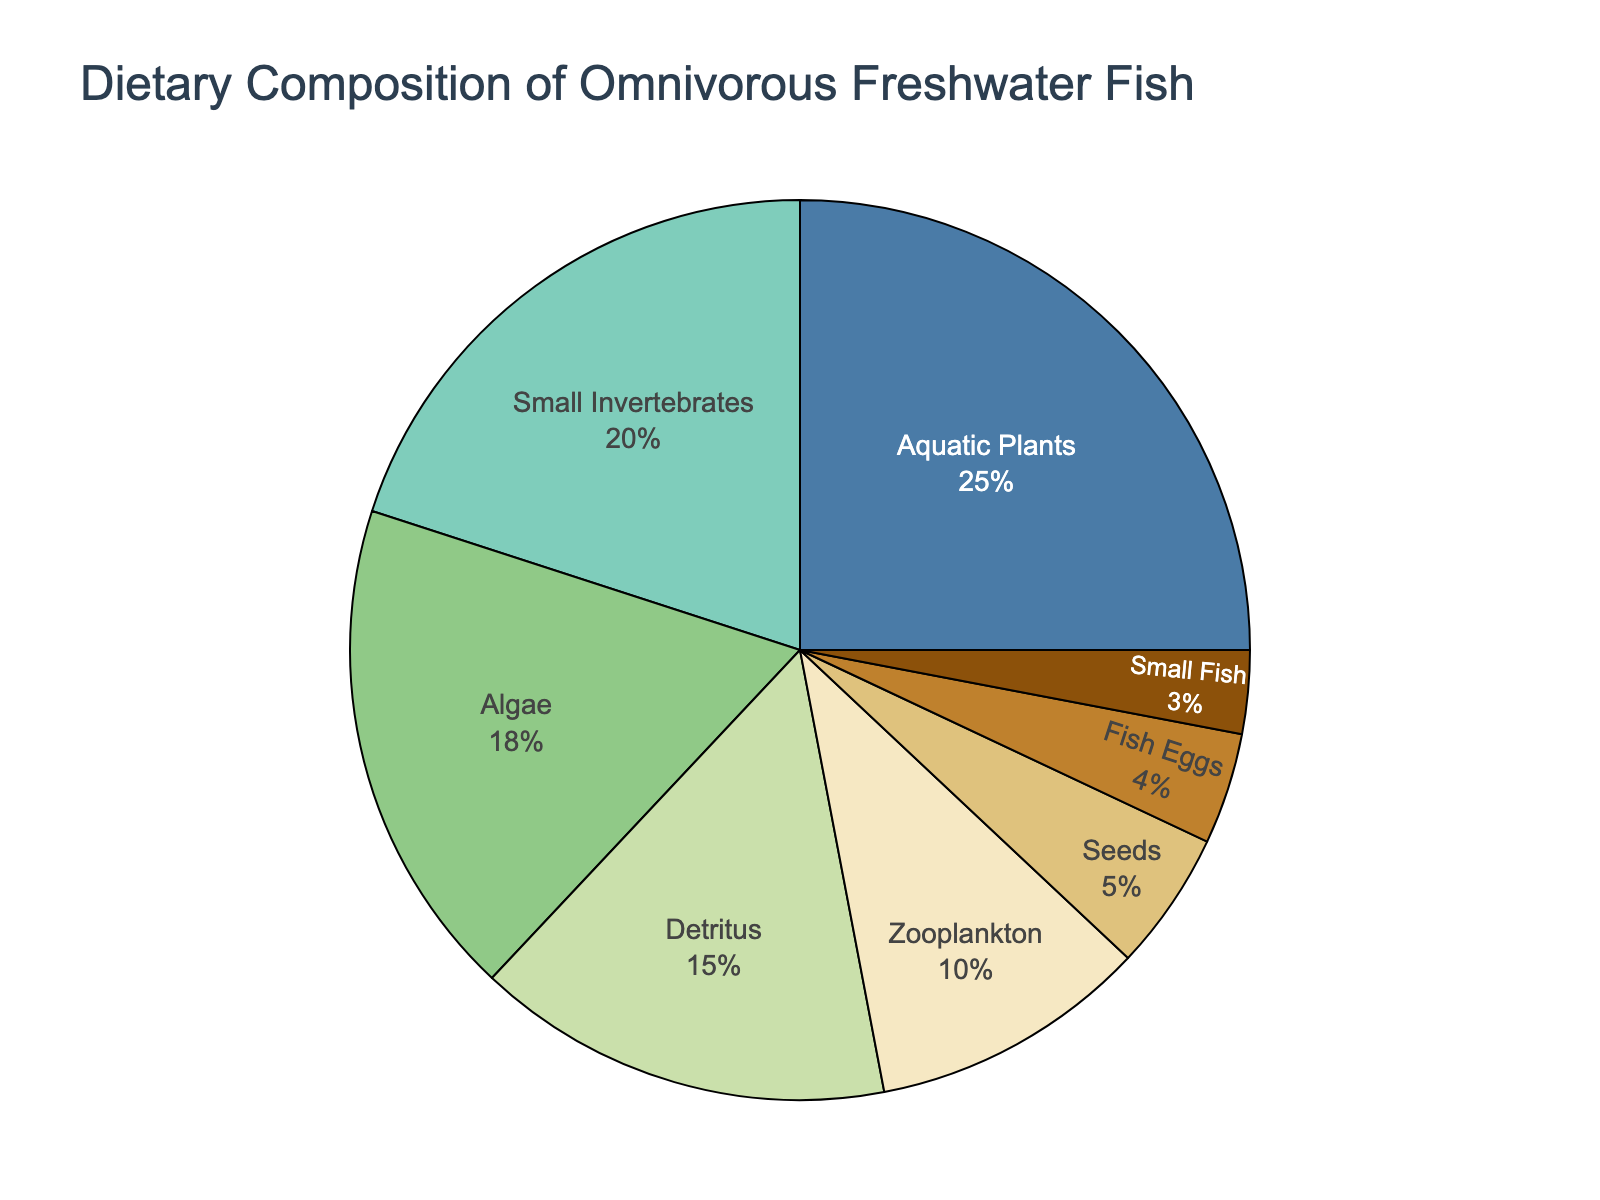What is the most common food item in the diet of omnivorous freshwater fish? The largest segment in the pie chart corresponds to "Aquatic Plants," which makes up 25% of the diet.
Answer: Aquatic Plants Which food item contributes the least to the diet of omnivorous freshwater fish? The smallest segment in the pie chart corresponds to "Small Fish," which makes up 3% of the diet.
Answer: Small Fish What is the difference in percentage between the consumption of aquatic plants and zooplankton? Aquatic Plants make up 25% of the diet, while Zooplankton make up 10%. The difference is 25% - 10% = 15%.
Answer: 15% Are algae consumed more or less than small invertebrates? Algae account for 18% and Small Invertebrates account for 20% of the diet. Therefore, Algae are consumed less.
Answer: Less What percentage of the diet is composed of seeds and fish eggs combined? Seeds make up 5% and Fish Eggs make up 4%. The combined percentage is 5% + 4% = 9%.
Answer: 9% How does the consumption of detritus compare to the consumption of algae? Detritus makes up 15% of the diet, while Algae make up 18%. Therefore, Detritus consumption is less than Algae.
Answer: Less Which food items make up more than 15% of the diet? The segments labeled "Aquatic Plants" (25%) and "Small Invertebrates" (20%) each make up more than 15% of the diet.
Answer: Aquatic Plants, Small Invertebrates What is the combined percentage of the least three consumed food items? The least consumed items are Small Fish (3%), Fish Eggs (4%), and Seeds (5%). The combined percentage is 3% + 4% + 5% = 12%.
Answer: 12% Which food item, visually represented in green, contributes to the diet, and what percentage does it represent? The green color is used for the "Small Invertebrates" segment, which makes up 20% of the diet.
Answer: Small Invertebrates, 20% What percentage of the diet consists of animal-based food items? Animal-based items include Small Invertebrates (20%), Zooplankton (10%), Fish Eggs (4%), and Small Fish (3%). The sum is 20% + 10% + 4% + 3% = 37%.
Answer: 37% 